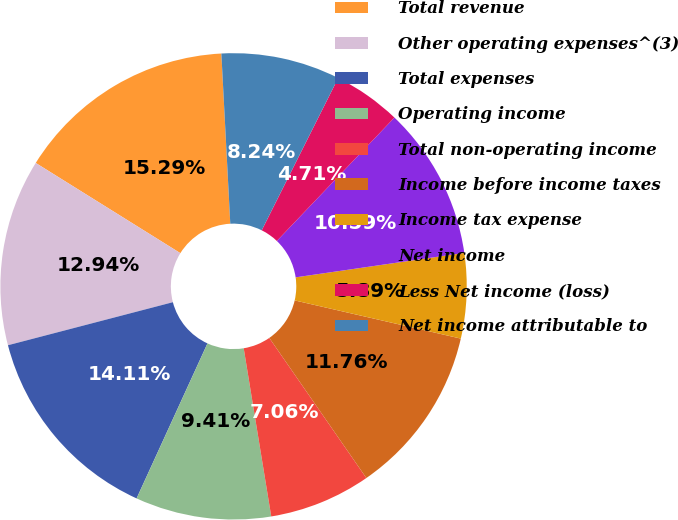Convert chart. <chart><loc_0><loc_0><loc_500><loc_500><pie_chart><fcel>Total revenue<fcel>Other operating expenses^(3)<fcel>Total expenses<fcel>Operating income<fcel>Total non-operating income<fcel>Income before income taxes<fcel>Income tax expense<fcel>Net income<fcel>Less Net income (loss)<fcel>Net income attributable to<nl><fcel>15.29%<fcel>12.94%<fcel>14.11%<fcel>9.41%<fcel>7.06%<fcel>11.76%<fcel>5.89%<fcel>10.59%<fcel>4.71%<fcel>8.24%<nl></chart> 